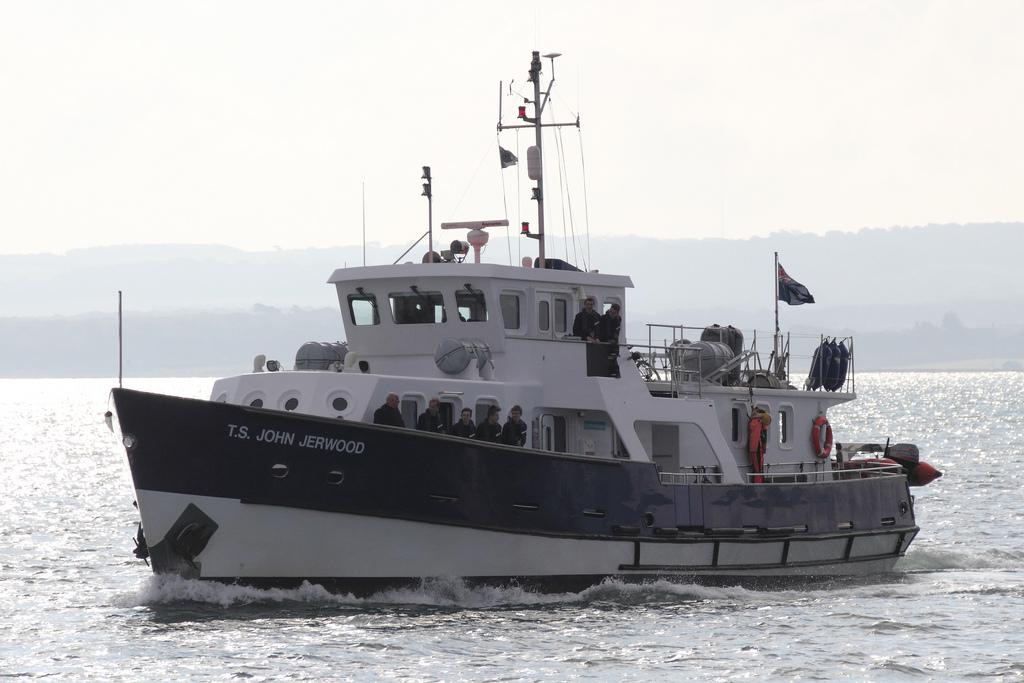Question: what does the boat have on its bow?
Choices:
A. A statue.
B. A plate.
C. A sign.
D. A flag.
Answer with the letter. Answer: D Question: what does the boat have facing front?
Choices:
A. Several round windows.
B. Captain's chair.
C. One steering wheel.
D. Two lights.
Answer with the letter. Answer: A Question: how is the weather?
Choices:
A. Rainy.
B. Snowy.
C. Cloudy and hazy.
D. Clear.
Answer with the letter. Answer: C Question: what is the boat doing?
Choices:
A. Nothing.
B. Docked.
C. Moving.
D. Kicking up waves.
Answer with the letter. Answer: D Question: who are on the boat?
Choices:
A. Several people.
B. No one.
C. A man and woman.
D. 6 men and 1 woman.
Answer with the letter. Answer: A Question: when will the boat stop moving?
Choices:
A. When it is anchored.
B. When the motor turns off.
C. When it docks.
D. When it runs out of gas.
Answer with the letter. Answer: C Question: who is on the boat?
Choices:
A. Fishermen.
B. Swimmers.
C. Passengers and crew.
D. Water skiiers.
Answer with the letter. Answer: C Question: what are the orange rings for?
Choices:
A. To throw if someone falls in the water.
B. To hold on to and float with.
C. To make yourself visible in the water.
D. For safety.
Answer with the letter. Answer: A Question: what is the total number of visible, open, flags?
Choices:
A. Two.
B. One.
C. Three.
D. Six.
Answer with the letter. Answer: A Question: why is there frothy water at the bottom of the boat?
Choices:
A. The wind is blowing hard.
B. The boat is moving with some speed, kicking up water.
C. The waves are hitting the edge of the boat.
D. The people are using paddles.
Answer with the letter. Answer: B Question: where are the people?
Choices:
A. On the bus.
B. Aboard the boat.
C. At the top of the tower.
D. In a vacation home.
Answer with the letter. Answer: B Question: what is in the water?
Choices:
A. The boat.
B. A shark.
C. The kayak.
D. Fish.
Answer with the letter. Answer: A Question: what is the name of this boat?
Choices:
A. Old Faithful.
B. Queen Mary II.
C. The Princess.
D. T. s. john jerwood.
Answer with the letter. Answer: D Question: why is the water hitting the front of the boat?
Choices:
A. Waves.
B. We are moving forward.
C. The wake of a boat.
D. Kids using a water gun.
Answer with the letter. Answer: A Question: how is the weather?
Choices:
A. Stormy.
B. Mild.
C. Cloudy.
D. Humid.
Answer with the letter. Answer: C Question: where is the life protection equipment?
Choices:
A. Inside the kitchen.
B. Hanging on the side of the boat.
C. Next to the steering wheel.
D. Under the boat seats.
Answer with the letter. Answer: B Question: where was the picture taken?
Choices:
A. By the beach.
B. In the ocean.
C. By the ocean.
D. By the school.
Answer with the letter. Answer: B Question: how does the weather appear?
Choices:
A. Sunny.
B. Foggy.
C. Cloudy.
D. Snowing.
Answer with the letter. Answer: B Question: what is the status of the boat?
Choices:
A. Not stationary.
B. Sunk.
C. At the pier.
D. Near the beach.
Answer with the letter. Answer: A Question: where is the anchor?
Choices:
A. On the bow.
B. In the water.
C. On the boat.
D. In the picture.
Answer with the letter. Answer: A Question: where was the picture taken?
Choices:
A. On the ocean.
B. On the beach.
C. On a lake.
D. Near a river.
Answer with the letter. Answer: A 